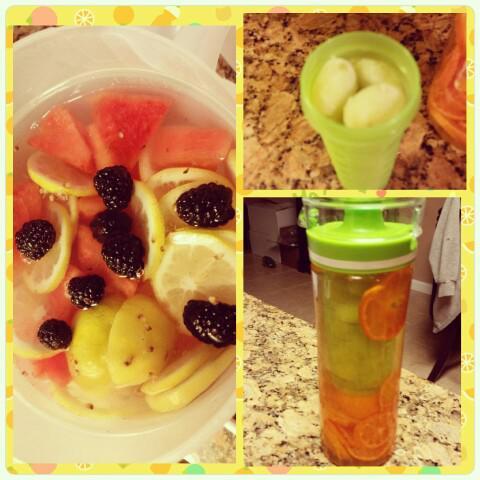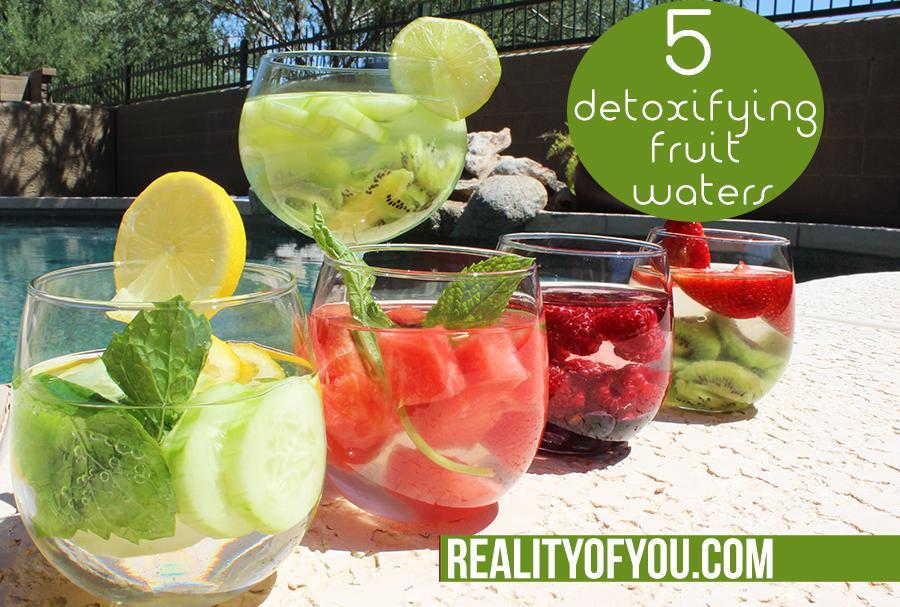The first image is the image on the left, the second image is the image on the right. Given the left and right images, does the statement "The right image shows four fruit-filled cylindrical jars arranged horizontally." hold true? Answer yes or no. No. 